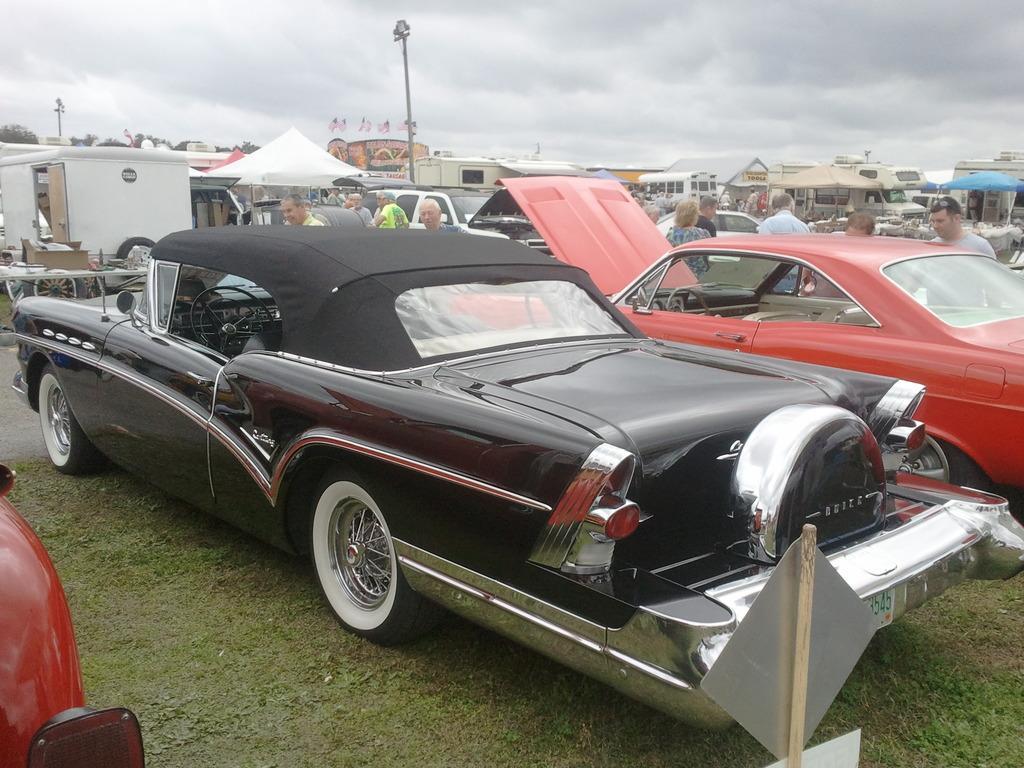Can you describe this image briefly? In this image there are so many people parked on the surface of the grass, in between them there are a few people standing and in the background there are camps, poles, buildings, trees and the sky. 